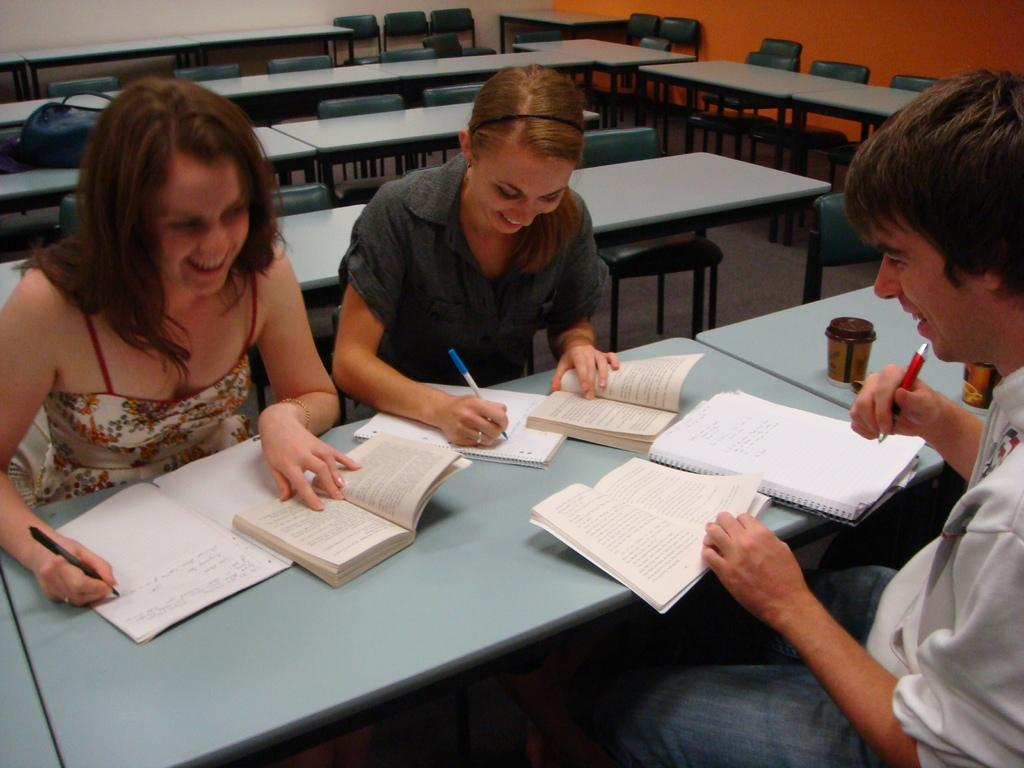What type of furniture is present in the image? There are tables and chairs in the image. What objects can be seen on the table? There are books and glasses on the table. How many people are in the image? There are three persons in the image. What are the persons holding? The persons are holding pens. Is there an uncle in the image? There is no mention of an uncle in the image or the provided facts. Can you see a stream in the image? There is no stream visible in the image. 